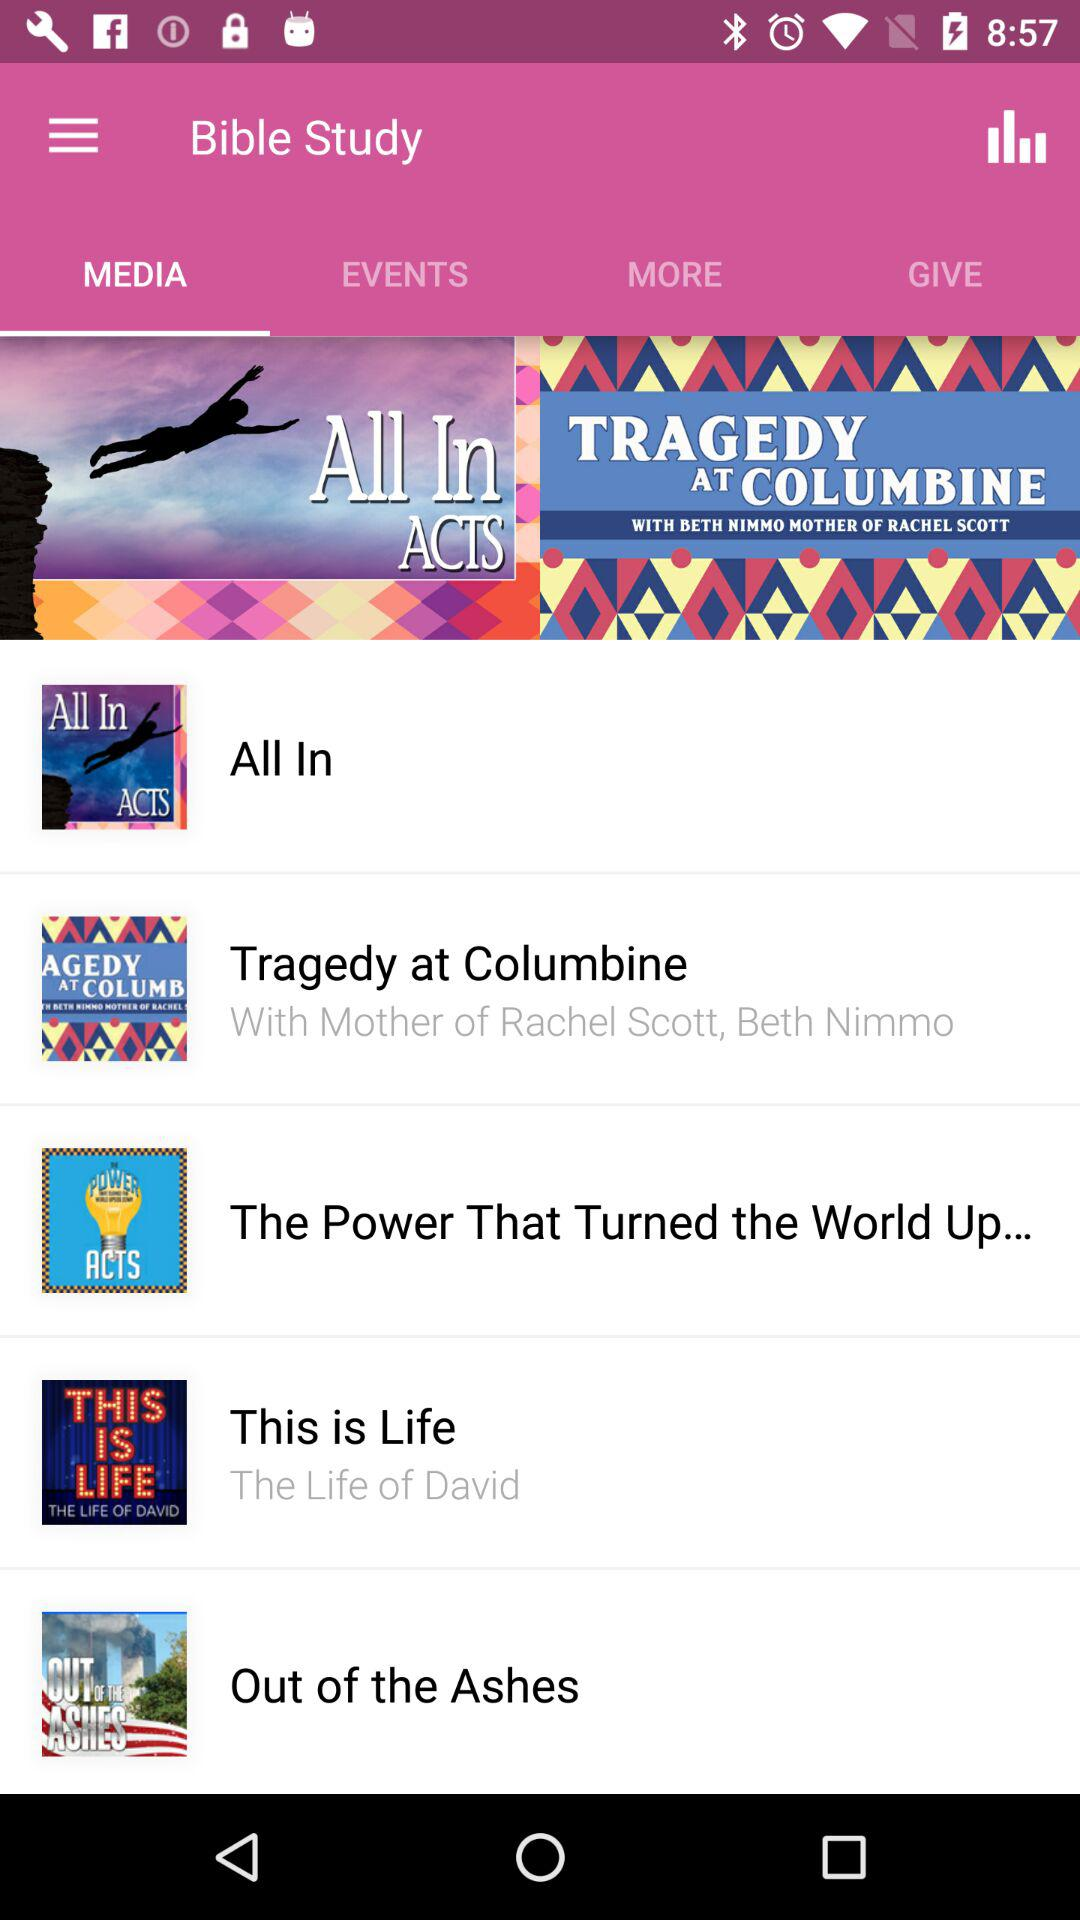What are the names of the media available on the screen? The names of the media are "All In", "Tragedy at Columbine", "The Power That Turned the World Up...", "This is Life", and "Out of the Ashes". 